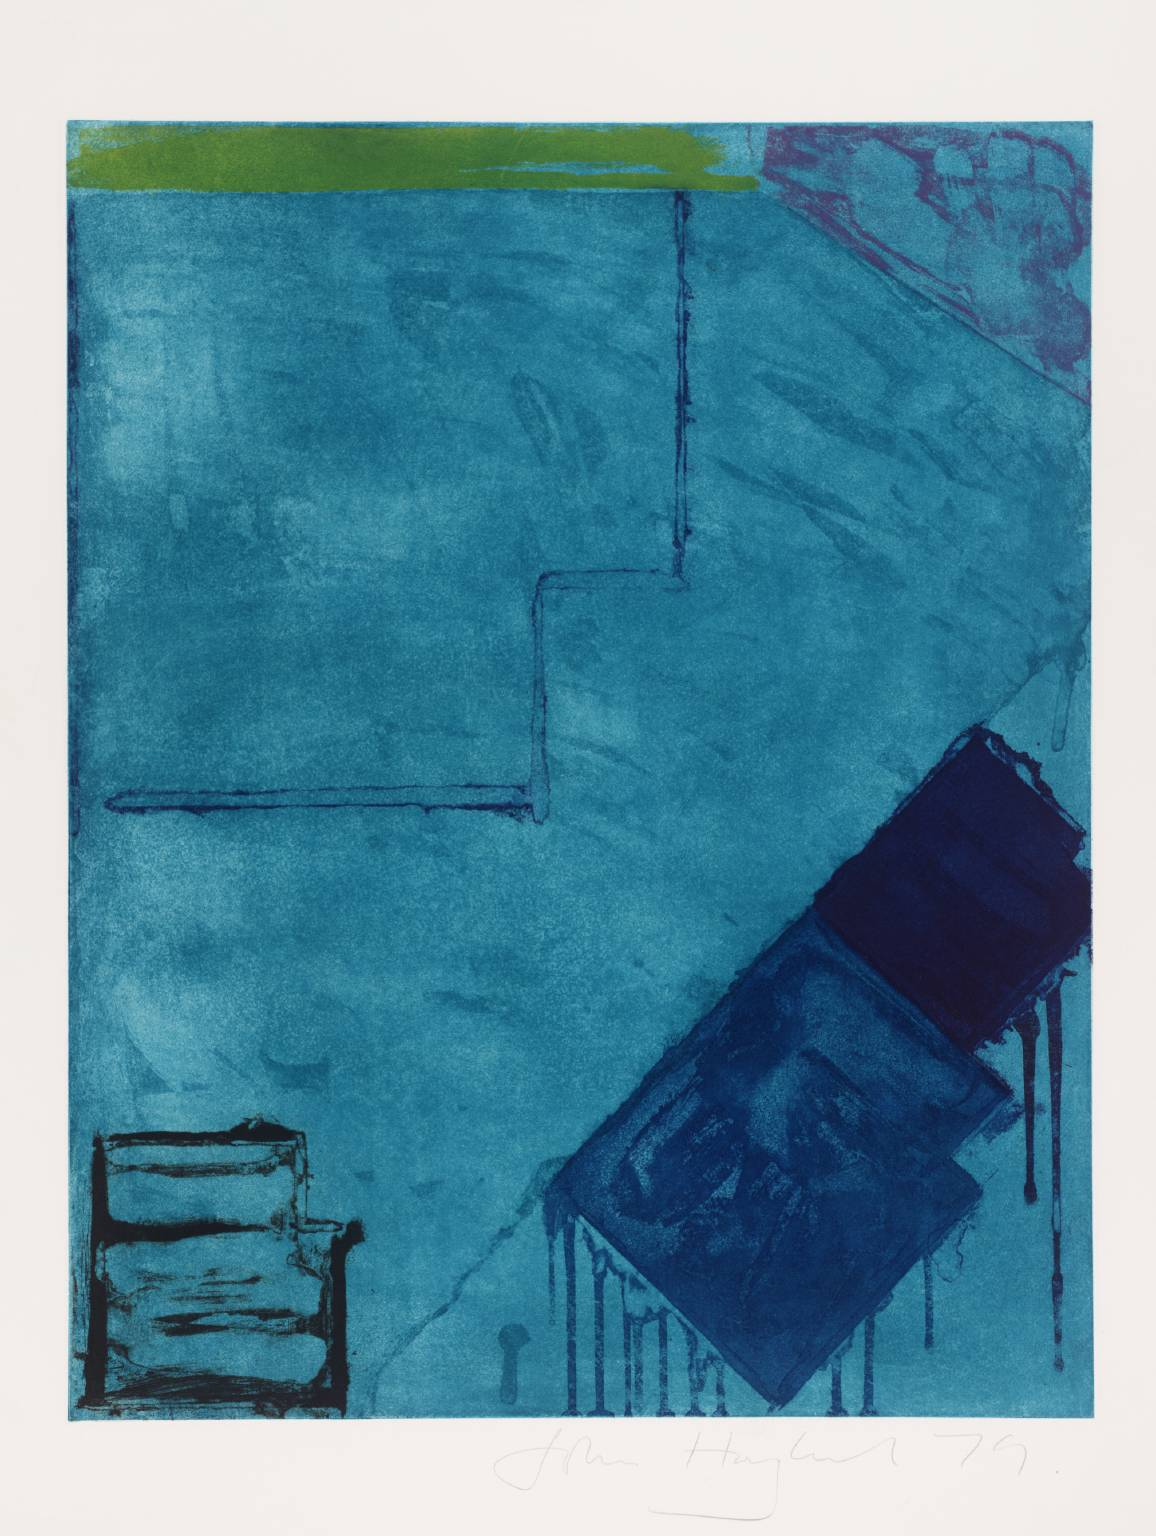Can you explain the significance of the green strip at the top of the artwork? The green strip at the top of the artwork might represent a horizon or a boundary, suggesting a thematic or visual division within the piece. It introduces a natural element in contrast to the more fluid and vast blue, which could symbolize the sky or a large body of water. This use of green could also be playing a role in balancing the composition, anchoring the eye and adding a sense of stability to the floating elements within the blue. 